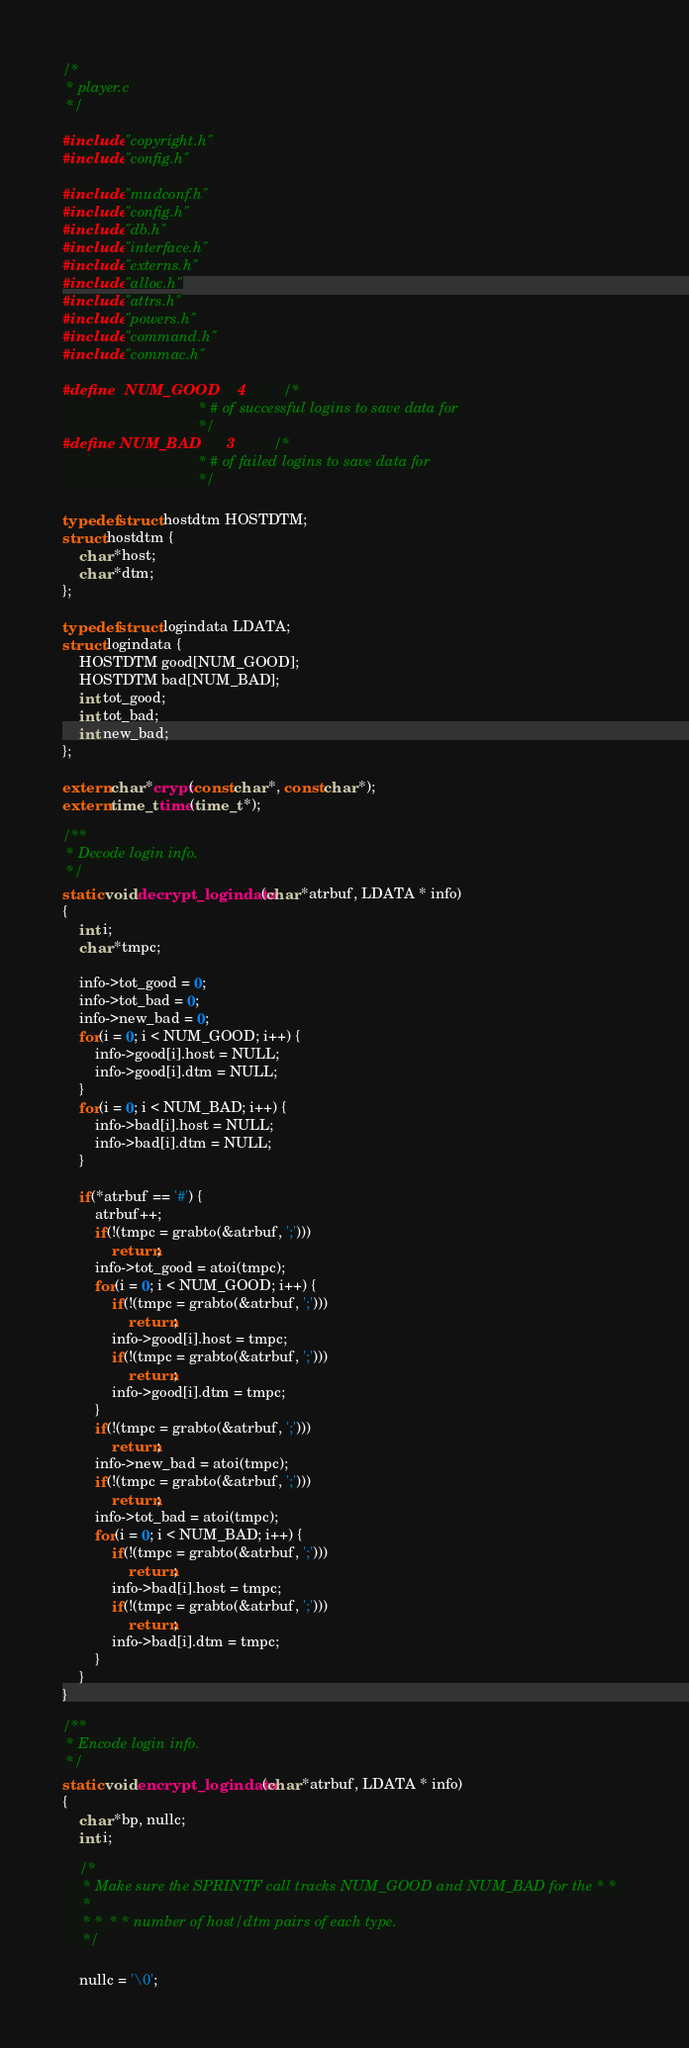<code> <loc_0><loc_0><loc_500><loc_500><_C_>
/*
 * player.c 
 */

#include "copyright.h"
#include "config.h"

#include "mudconf.h"
#include "config.h"
#include "db.h"
#include "interface.h"
#include "externs.h"
#include "alloc.h"
#include "attrs.h"
#include "powers.h"
#include "command.h"
#include "commac.h"

#define	NUM_GOOD	4			/*
								 * # of successful logins to save data for 
								 */
#define NUM_BAD		3			/*
								 * # of failed logins to save data for 
								 */

typedef struct hostdtm HOSTDTM;
struct hostdtm {
	char *host;
	char *dtm;
};

typedef struct logindata LDATA;
struct logindata {
	HOSTDTM good[NUM_GOOD];
	HOSTDTM bad[NUM_BAD];
	int tot_good;
	int tot_bad;
	int new_bad;
};

extern char *crypt(const char *, const char *);
extern time_t time(time_t *);

/**
 * Decode login info.
 */
static void decrypt_logindata(char *atrbuf, LDATA * info)
{
	int i;
	char *tmpc;

	info->tot_good = 0;
	info->tot_bad = 0;
	info->new_bad = 0;
	for(i = 0; i < NUM_GOOD; i++) {
		info->good[i].host = NULL;
		info->good[i].dtm = NULL;
	}
	for(i = 0; i < NUM_BAD; i++) {
		info->bad[i].host = NULL;
		info->bad[i].dtm = NULL;
	}

	if(*atrbuf == '#') {
		atrbuf++;
		if(!(tmpc = grabto(&atrbuf, ';')))
			return;
		info->tot_good = atoi(tmpc);
		for(i = 0; i < NUM_GOOD; i++) {
			if(!(tmpc = grabto(&atrbuf, ';')))
				return;
			info->good[i].host = tmpc;
			if(!(tmpc = grabto(&atrbuf, ';')))
				return;
			info->good[i].dtm = tmpc;
		}
		if(!(tmpc = grabto(&atrbuf, ';')))
			return;
		info->new_bad = atoi(tmpc);
		if(!(tmpc = grabto(&atrbuf, ';')))
			return;
		info->tot_bad = atoi(tmpc);
		for(i = 0; i < NUM_BAD; i++) {
			if(!(tmpc = grabto(&atrbuf, ';')))
				return;
			info->bad[i].host = tmpc;
			if(!(tmpc = grabto(&atrbuf, ';')))
				return;
			info->bad[i].dtm = tmpc;
		}
	}
}

/**
 * Encode login info.
 */
static void encrypt_logindata(char *atrbuf, LDATA * info)
{
	char *bp, nullc;
	int i;

	/*
	 * Make sure the SPRINTF call tracks NUM_GOOD and NUM_BAD for the * * 
	 * 
	 * *  * * number of host/dtm pairs of each type. 
	 */

	nullc = '\0';</code> 